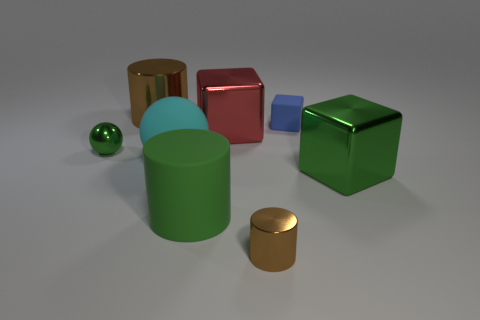Subtract all large red cubes. How many cubes are left? 2 Add 2 large brown cylinders. How many objects exist? 10 Subtract all green cylinders. How many cylinders are left? 2 Subtract all red balls. How many brown cylinders are left? 2 Add 3 green blocks. How many green blocks are left? 4 Add 2 cyan blocks. How many cyan blocks exist? 2 Subtract 0 blue cylinders. How many objects are left? 8 Subtract all cubes. How many objects are left? 5 Subtract 3 cylinders. How many cylinders are left? 0 Subtract all yellow balls. Subtract all blue cubes. How many balls are left? 2 